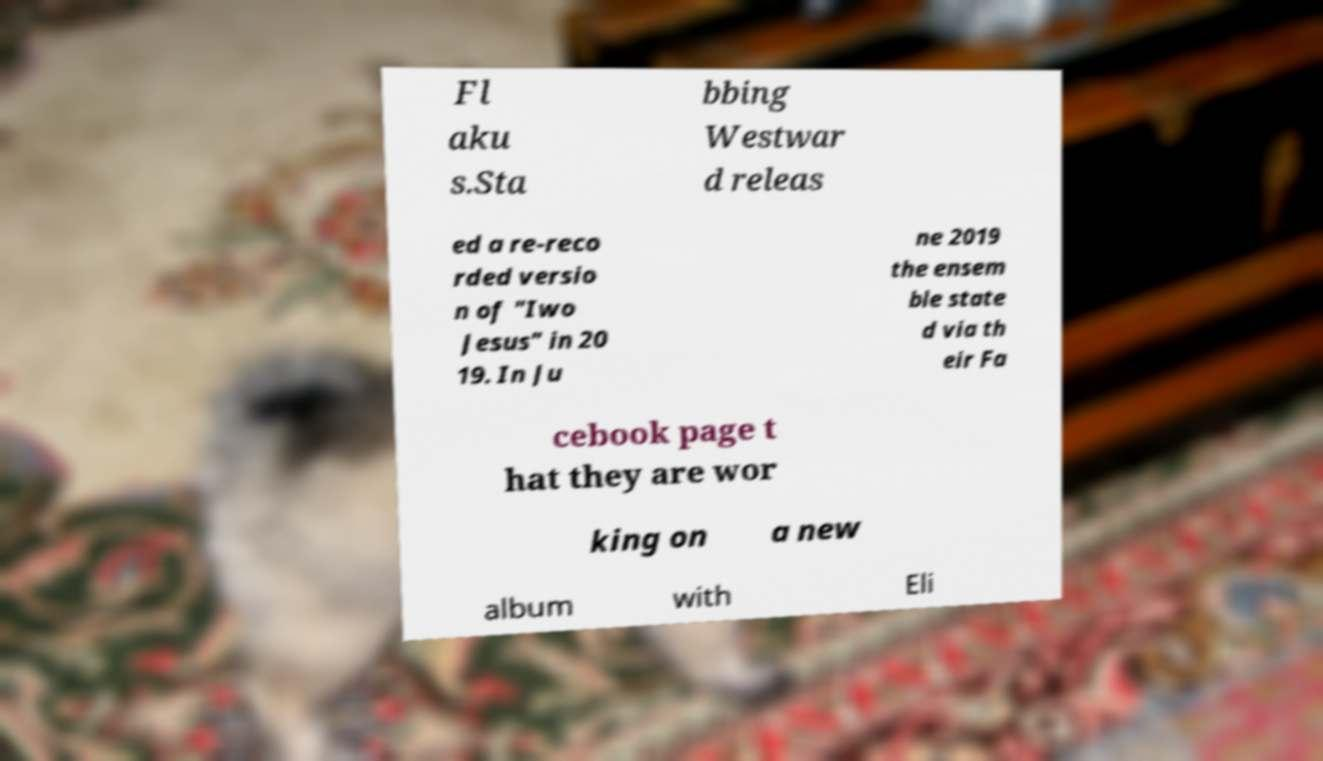I need the written content from this picture converted into text. Can you do that? Fl aku s.Sta bbing Westwar d releas ed a re-reco rded versio n of "Iwo Jesus" in 20 19. In Ju ne 2019 the ensem ble state d via th eir Fa cebook page t hat they are wor king on a new album with Eli 